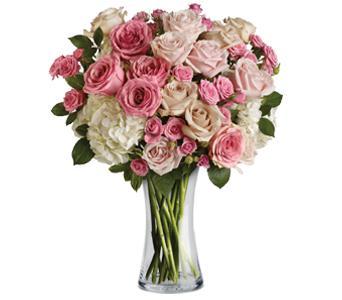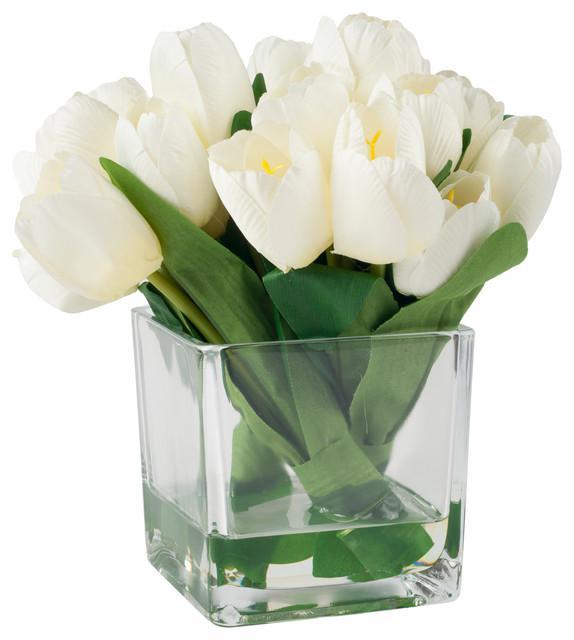The first image is the image on the left, the second image is the image on the right. Assess this claim about the two images: "One of the images contains white flowers". Correct or not? Answer yes or no. Yes. 